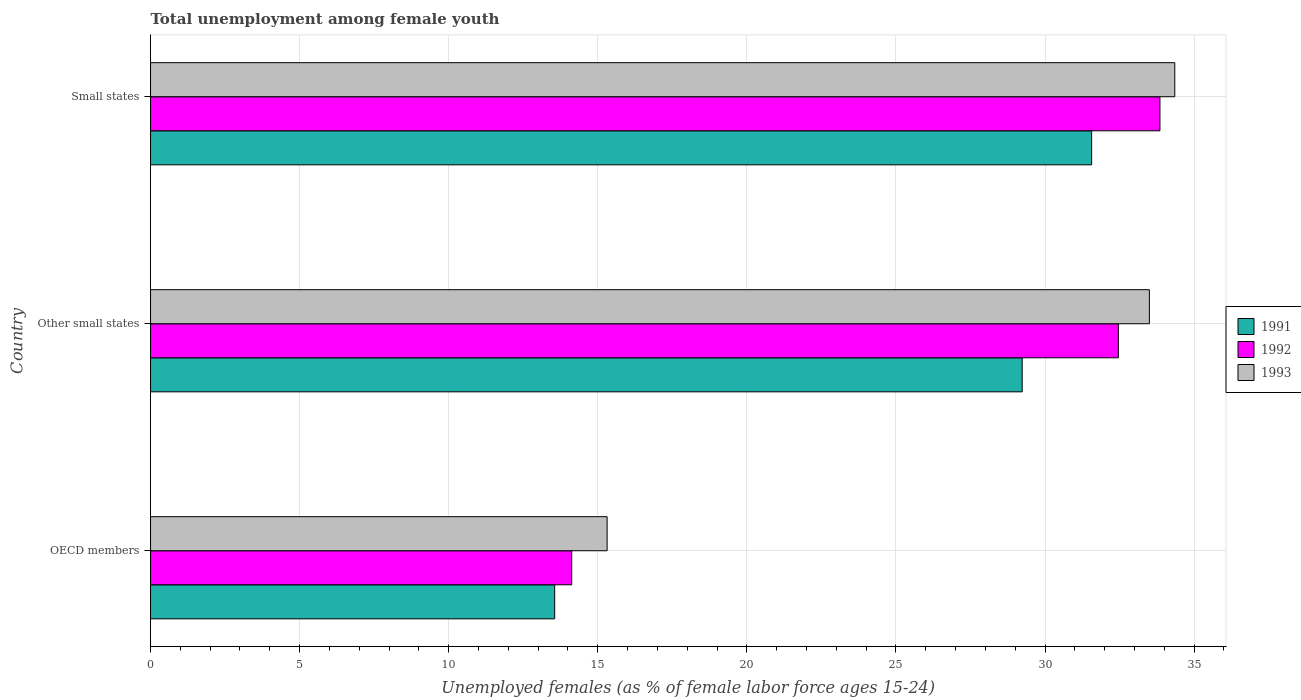Are the number of bars on each tick of the Y-axis equal?
Your response must be concise. Yes. How many bars are there on the 3rd tick from the top?
Provide a succinct answer. 3. How many bars are there on the 2nd tick from the bottom?
Keep it short and to the point. 3. What is the label of the 1st group of bars from the top?
Your answer should be very brief. Small states. In how many cases, is the number of bars for a given country not equal to the number of legend labels?
Offer a very short reply. 0. What is the percentage of unemployed females in in 1993 in OECD members?
Your answer should be very brief. 15.31. Across all countries, what is the maximum percentage of unemployed females in in 1992?
Provide a short and direct response. 33.85. Across all countries, what is the minimum percentage of unemployed females in in 1991?
Your answer should be compact. 13.55. In which country was the percentage of unemployed females in in 1992 maximum?
Your response must be concise. Small states. In which country was the percentage of unemployed females in in 1993 minimum?
Your response must be concise. OECD members. What is the total percentage of unemployed females in in 1991 in the graph?
Offer a very short reply. 74.35. What is the difference between the percentage of unemployed females in in 1991 in Other small states and that in Small states?
Make the answer very short. -2.33. What is the difference between the percentage of unemployed females in in 1992 in Other small states and the percentage of unemployed females in in 1991 in Small states?
Offer a very short reply. 0.9. What is the average percentage of unemployed females in in 1992 per country?
Keep it short and to the point. 26.81. What is the difference between the percentage of unemployed females in in 1993 and percentage of unemployed females in in 1991 in Small states?
Your answer should be very brief. 2.79. In how many countries, is the percentage of unemployed females in in 1993 greater than 32 %?
Give a very brief answer. 2. What is the ratio of the percentage of unemployed females in in 1991 in OECD members to that in Small states?
Your response must be concise. 0.43. Is the percentage of unemployed females in in 1991 in OECD members less than that in Other small states?
Make the answer very short. Yes. Is the difference between the percentage of unemployed females in in 1993 in OECD members and Other small states greater than the difference between the percentage of unemployed females in in 1991 in OECD members and Other small states?
Keep it short and to the point. No. What is the difference between the highest and the second highest percentage of unemployed females in in 1991?
Offer a terse response. 2.33. What is the difference between the highest and the lowest percentage of unemployed females in in 1991?
Your response must be concise. 18.01. Is it the case that in every country, the sum of the percentage of unemployed females in in 1991 and percentage of unemployed females in in 1993 is greater than the percentage of unemployed females in in 1992?
Give a very brief answer. Yes. How many bars are there?
Make the answer very short. 9. Are all the bars in the graph horizontal?
Ensure brevity in your answer.  Yes. What is the difference between two consecutive major ticks on the X-axis?
Offer a terse response. 5. Does the graph contain any zero values?
Ensure brevity in your answer.  No. Does the graph contain grids?
Your answer should be compact. Yes. How are the legend labels stacked?
Your answer should be compact. Vertical. What is the title of the graph?
Provide a short and direct response. Total unemployment among female youth. What is the label or title of the X-axis?
Keep it short and to the point. Unemployed females (as % of female labor force ages 15-24). What is the label or title of the Y-axis?
Offer a very short reply. Country. What is the Unemployed females (as % of female labor force ages 15-24) in 1991 in OECD members?
Offer a terse response. 13.55. What is the Unemployed females (as % of female labor force ages 15-24) of 1992 in OECD members?
Give a very brief answer. 14.13. What is the Unemployed females (as % of female labor force ages 15-24) of 1993 in OECD members?
Keep it short and to the point. 15.31. What is the Unemployed females (as % of female labor force ages 15-24) in 1991 in Other small states?
Keep it short and to the point. 29.23. What is the Unemployed females (as % of female labor force ages 15-24) of 1992 in Other small states?
Provide a short and direct response. 32.46. What is the Unemployed females (as % of female labor force ages 15-24) in 1993 in Other small states?
Your answer should be very brief. 33.5. What is the Unemployed females (as % of female labor force ages 15-24) in 1991 in Small states?
Give a very brief answer. 31.56. What is the Unemployed females (as % of female labor force ages 15-24) of 1992 in Small states?
Your answer should be compact. 33.85. What is the Unemployed females (as % of female labor force ages 15-24) of 1993 in Small states?
Your answer should be compact. 34.35. Across all countries, what is the maximum Unemployed females (as % of female labor force ages 15-24) of 1991?
Provide a short and direct response. 31.56. Across all countries, what is the maximum Unemployed females (as % of female labor force ages 15-24) of 1992?
Offer a very short reply. 33.85. Across all countries, what is the maximum Unemployed females (as % of female labor force ages 15-24) of 1993?
Your answer should be compact. 34.35. Across all countries, what is the minimum Unemployed females (as % of female labor force ages 15-24) in 1991?
Offer a terse response. 13.55. Across all countries, what is the minimum Unemployed females (as % of female labor force ages 15-24) in 1992?
Offer a terse response. 14.13. Across all countries, what is the minimum Unemployed females (as % of female labor force ages 15-24) in 1993?
Ensure brevity in your answer.  15.31. What is the total Unemployed females (as % of female labor force ages 15-24) in 1991 in the graph?
Ensure brevity in your answer.  74.35. What is the total Unemployed females (as % of female labor force ages 15-24) of 1992 in the graph?
Offer a very short reply. 80.44. What is the total Unemployed females (as % of female labor force ages 15-24) of 1993 in the graph?
Offer a very short reply. 83.17. What is the difference between the Unemployed females (as % of female labor force ages 15-24) in 1991 in OECD members and that in Other small states?
Provide a short and direct response. -15.68. What is the difference between the Unemployed females (as % of female labor force ages 15-24) in 1992 in OECD members and that in Other small states?
Your response must be concise. -18.34. What is the difference between the Unemployed females (as % of female labor force ages 15-24) of 1993 in OECD members and that in Other small states?
Provide a succinct answer. -18.19. What is the difference between the Unemployed females (as % of female labor force ages 15-24) of 1991 in OECD members and that in Small states?
Give a very brief answer. -18.01. What is the difference between the Unemployed females (as % of female labor force ages 15-24) in 1992 in OECD members and that in Small states?
Provide a succinct answer. -19.73. What is the difference between the Unemployed females (as % of female labor force ages 15-24) of 1993 in OECD members and that in Small states?
Provide a short and direct response. -19.04. What is the difference between the Unemployed females (as % of female labor force ages 15-24) in 1991 in Other small states and that in Small states?
Your response must be concise. -2.33. What is the difference between the Unemployed females (as % of female labor force ages 15-24) in 1992 in Other small states and that in Small states?
Keep it short and to the point. -1.39. What is the difference between the Unemployed females (as % of female labor force ages 15-24) of 1993 in Other small states and that in Small states?
Ensure brevity in your answer.  -0.85. What is the difference between the Unemployed females (as % of female labor force ages 15-24) in 1991 in OECD members and the Unemployed females (as % of female labor force ages 15-24) in 1992 in Other small states?
Give a very brief answer. -18.91. What is the difference between the Unemployed females (as % of female labor force ages 15-24) of 1991 in OECD members and the Unemployed females (as % of female labor force ages 15-24) of 1993 in Other small states?
Your response must be concise. -19.95. What is the difference between the Unemployed females (as % of female labor force ages 15-24) of 1992 in OECD members and the Unemployed females (as % of female labor force ages 15-24) of 1993 in Other small states?
Provide a short and direct response. -19.37. What is the difference between the Unemployed females (as % of female labor force ages 15-24) in 1991 in OECD members and the Unemployed females (as % of female labor force ages 15-24) in 1992 in Small states?
Your answer should be compact. -20.3. What is the difference between the Unemployed females (as % of female labor force ages 15-24) of 1991 in OECD members and the Unemployed females (as % of female labor force ages 15-24) of 1993 in Small states?
Make the answer very short. -20.8. What is the difference between the Unemployed females (as % of female labor force ages 15-24) in 1992 in OECD members and the Unemployed females (as % of female labor force ages 15-24) in 1993 in Small states?
Offer a terse response. -20.23. What is the difference between the Unemployed females (as % of female labor force ages 15-24) in 1991 in Other small states and the Unemployed females (as % of female labor force ages 15-24) in 1992 in Small states?
Offer a terse response. -4.62. What is the difference between the Unemployed females (as % of female labor force ages 15-24) in 1991 in Other small states and the Unemployed females (as % of female labor force ages 15-24) in 1993 in Small states?
Provide a succinct answer. -5.12. What is the difference between the Unemployed females (as % of female labor force ages 15-24) in 1992 in Other small states and the Unemployed females (as % of female labor force ages 15-24) in 1993 in Small states?
Offer a very short reply. -1.89. What is the average Unemployed females (as % of female labor force ages 15-24) in 1991 per country?
Provide a succinct answer. 24.78. What is the average Unemployed females (as % of female labor force ages 15-24) in 1992 per country?
Your answer should be compact. 26.81. What is the average Unemployed females (as % of female labor force ages 15-24) in 1993 per country?
Your answer should be compact. 27.72. What is the difference between the Unemployed females (as % of female labor force ages 15-24) in 1991 and Unemployed females (as % of female labor force ages 15-24) in 1992 in OECD members?
Provide a short and direct response. -0.57. What is the difference between the Unemployed females (as % of female labor force ages 15-24) of 1991 and Unemployed females (as % of female labor force ages 15-24) of 1993 in OECD members?
Offer a terse response. -1.76. What is the difference between the Unemployed females (as % of female labor force ages 15-24) in 1992 and Unemployed females (as % of female labor force ages 15-24) in 1993 in OECD members?
Make the answer very short. -1.19. What is the difference between the Unemployed females (as % of female labor force ages 15-24) in 1991 and Unemployed females (as % of female labor force ages 15-24) in 1992 in Other small states?
Provide a succinct answer. -3.23. What is the difference between the Unemployed females (as % of female labor force ages 15-24) of 1991 and Unemployed females (as % of female labor force ages 15-24) of 1993 in Other small states?
Offer a very short reply. -4.27. What is the difference between the Unemployed females (as % of female labor force ages 15-24) of 1992 and Unemployed females (as % of female labor force ages 15-24) of 1993 in Other small states?
Offer a very short reply. -1.04. What is the difference between the Unemployed females (as % of female labor force ages 15-24) of 1991 and Unemployed females (as % of female labor force ages 15-24) of 1992 in Small states?
Your answer should be very brief. -2.29. What is the difference between the Unemployed females (as % of female labor force ages 15-24) in 1991 and Unemployed females (as % of female labor force ages 15-24) in 1993 in Small states?
Give a very brief answer. -2.79. What is the difference between the Unemployed females (as % of female labor force ages 15-24) in 1992 and Unemployed females (as % of female labor force ages 15-24) in 1993 in Small states?
Your answer should be compact. -0.5. What is the ratio of the Unemployed females (as % of female labor force ages 15-24) in 1991 in OECD members to that in Other small states?
Keep it short and to the point. 0.46. What is the ratio of the Unemployed females (as % of female labor force ages 15-24) in 1992 in OECD members to that in Other small states?
Provide a short and direct response. 0.44. What is the ratio of the Unemployed females (as % of female labor force ages 15-24) in 1993 in OECD members to that in Other small states?
Make the answer very short. 0.46. What is the ratio of the Unemployed females (as % of female labor force ages 15-24) of 1991 in OECD members to that in Small states?
Make the answer very short. 0.43. What is the ratio of the Unemployed females (as % of female labor force ages 15-24) of 1992 in OECD members to that in Small states?
Provide a short and direct response. 0.42. What is the ratio of the Unemployed females (as % of female labor force ages 15-24) in 1993 in OECD members to that in Small states?
Give a very brief answer. 0.45. What is the ratio of the Unemployed females (as % of female labor force ages 15-24) of 1991 in Other small states to that in Small states?
Your response must be concise. 0.93. What is the ratio of the Unemployed females (as % of female labor force ages 15-24) in 1992 in Other small states to that in Small states?
Make the answer very short. 0.96. What is the ratio of the Unemployed females (as % of female labor force ages 15-24) of 1993 in Other small states to that in Small states?
Ensure brevity in your answer.  0.98. What is the difference between the highest and the second highest Unemployed females (as % of female labor force ages 15-24) of 1991?
Offer a terse response. 2.33. What is the difference between the highest and the second highest Unemployed females (as % of female labor force ages 15-24) of 1992?
Offer a terse response. 1.39. What is the difference between the highest and the second highest Unemployed females (as % of female labor force ages 15-24) of 1993?
Give a very brief answer. 0.85. What is the difference between the highest and the lowest Unemployed females (as % of female labor force ages 15-24) of 1991?
Make the answer very short. 18.01. What is the difference between the highest and the lowest Unemployed females (as % of female labor force ages 15-24) in 1992?
Make the answer very short. 19.73. What is the difference between the highest and the lowest Unemployed females (as % of female labor force ages 15-24) of 1993?
Keep it short and to the point. 19.04. 